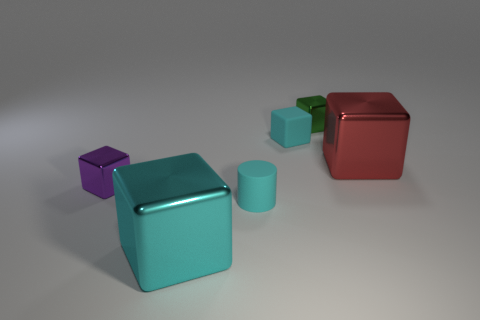Subtract all cyan blocks. How many blocks are left? 3 Add 2 large brown shiny cylinders. How many objects exist? 8 Subtract all cyan blocks. How many blocks are left? 3 Subtract all cubes. How many objects are left? 1 Subtract all metallic objects. Subtract all small green metallic cubes. How many objects are left? 1 Add 1 large cyan cubes. How many large cyan cubes are left? 2 Add 6 matte blocks. How many matte blocks exist? 7 Subtract 1 purple blocks. How many objects are left? 5 Subtract 4 blocks. How many blocks are left? 1 Subtract all brown blocks. Subtract all yellow cylinders. How many blocks are left? 5 